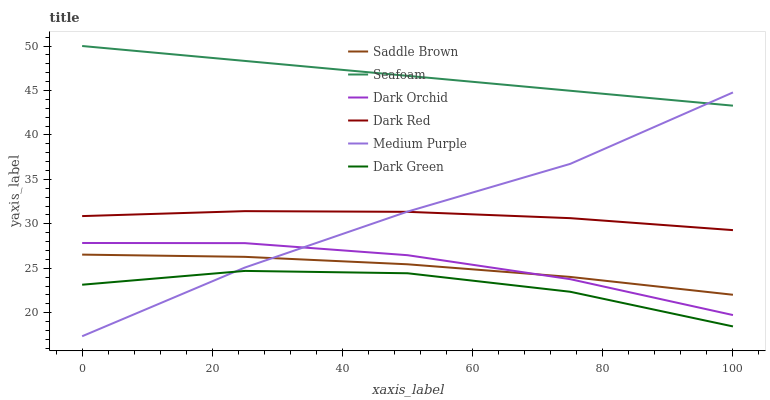Does Dark Green have the minimum area under the curve?
Answer yes or no. Yes. Does Seafoam have the maximum area under the curve?
Answer yes or no. Yes. Does Dark Orchid have the minimum area under the curve?
Answer yes or no. No. Does Dark Orchid have the maximum area under the curve?
Answer yes or no. No. Is Seafoam the smoothest?
Answer yes or no. Yes. Is Dark Green the roughest?
Answer yes or no. Yes. Is Dark Orchid the smoothest?
Answer yes or no. No. Is Dark Orchid the roughest?
Answer yes or no. No. Does Medium Purple have the lowest value?
Answer yes or no. Yes. Does Dark Orchid have the lowest value?
Answer yes or no. No. Does Seafoam have the highest value?
Answer yes or no. Yes. Does Dark Orchid have the highest value?
Answer yes or no. No. Is Saddle Brown less than Dark Red?
Answer yes or no. Yes. Is Seafoam greater than Dark Green?
Answer yes or no. Yes. Does Medium Purple intersect Seafoam?
Answer yes or no. Yes. Is Medium Purple less than Seafoam?
Answer yes or no. No. Is Medium Purple greater than Seafoam?
Answer yes or no. No. Does Saddle Brown intersect Dark Red?
Answer yes or no. No. 